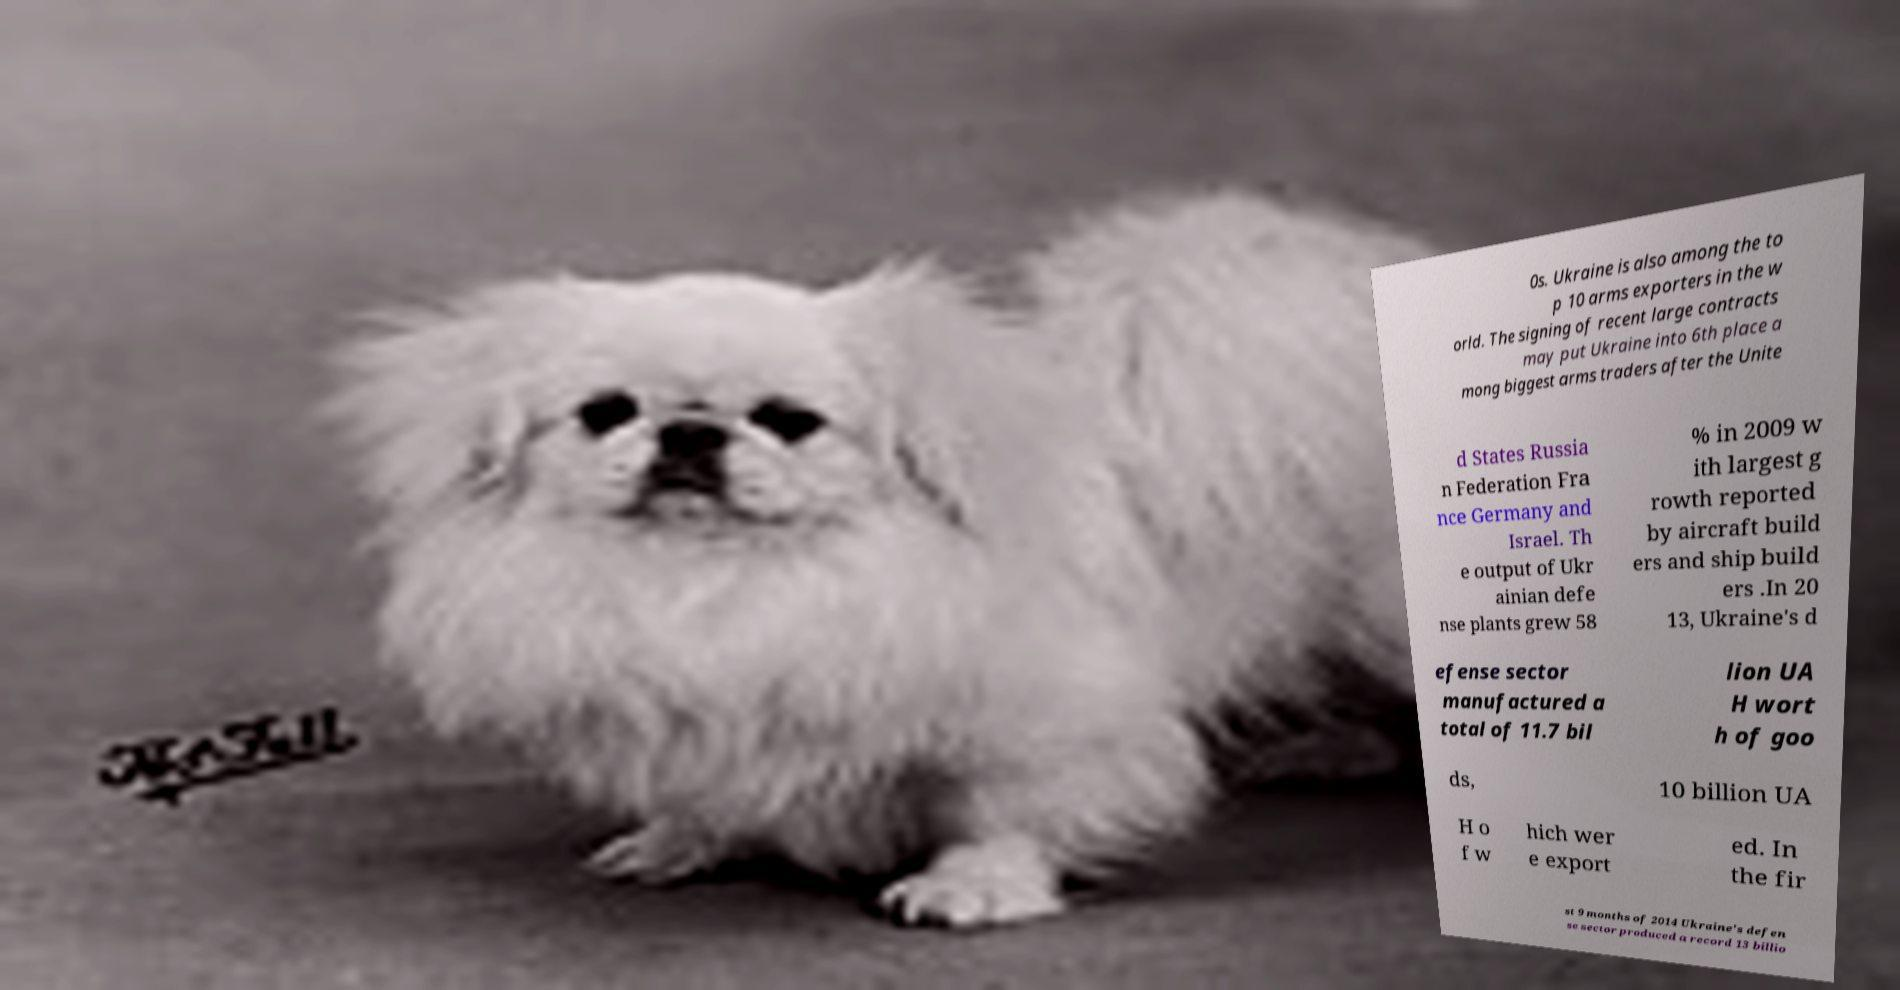Can you accurately transcribe the text from the provided image for me? 0s. Ukraine is also among the to p 10 arms exporters in the w orld. The signing of recent large contracts may put Ukraine into 6th place a mong biggest arms traders after the Unite d States Russia n Federation Fra nce Germany and Israel. Th e output of Ukr ainian defe nse plants grew 58 % in 2009 w ith largest g rowth reported by aircraft build ers and ship build ers .In 20 13, Ukraine's d efense sector manufactured a total of 11.7 bil lion UA H wort h of goo ds, 10 billion UA H o f w hich wer e export ed. In the fir st 9 months of 2014 Ukraine's defen se sector produced a record 13 billio 